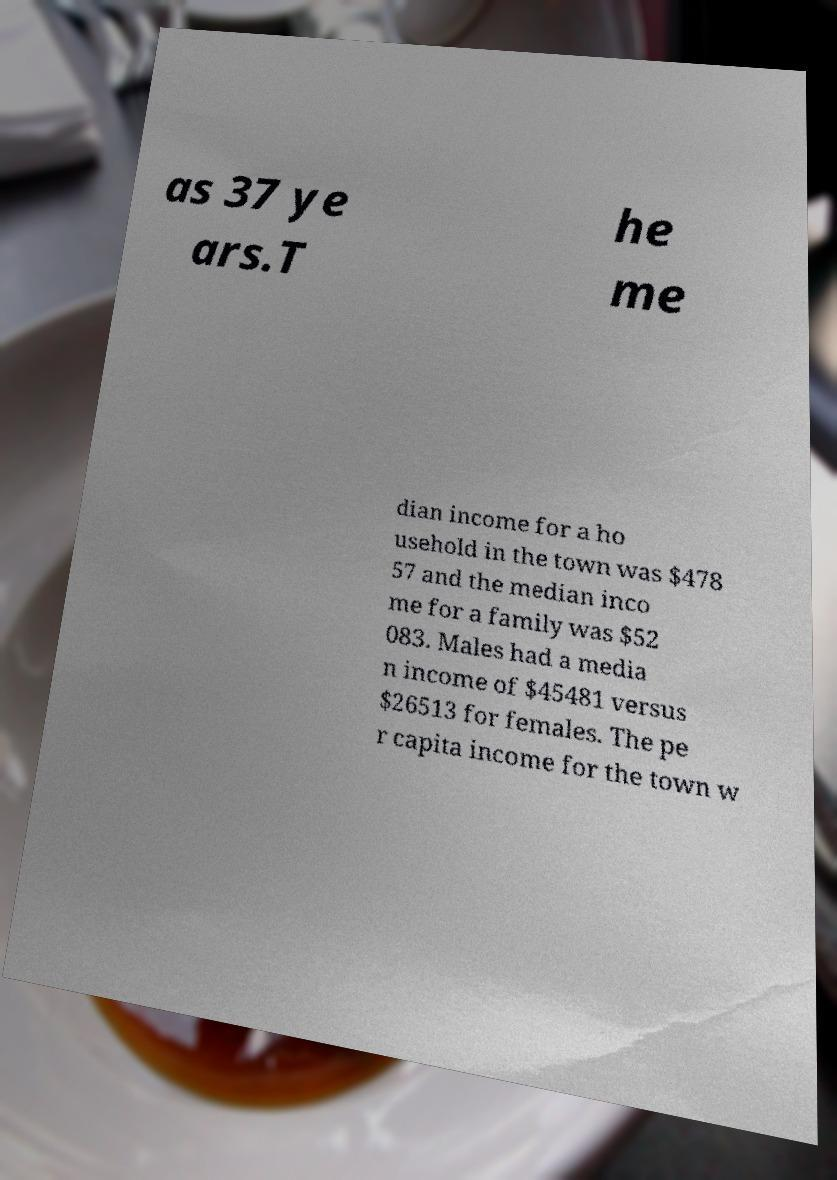Could you extract and type out the text from this image? as 37 ye ars.T he me dian income for a ho usehold in the town was $478 57 and the median inco me for a family was $52 083. Males had a media n income of $45481 versus $26513 for females. The pe r capita income for the town w 